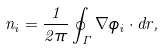<formula> <loc_0><loc_0><loc_500><loc_500>n _ { i } = \frac { 1 } { 2 \pi } \oint _ { \Gamma } \nabla \phi _ { i } \cdot d { r } ,</formula> 